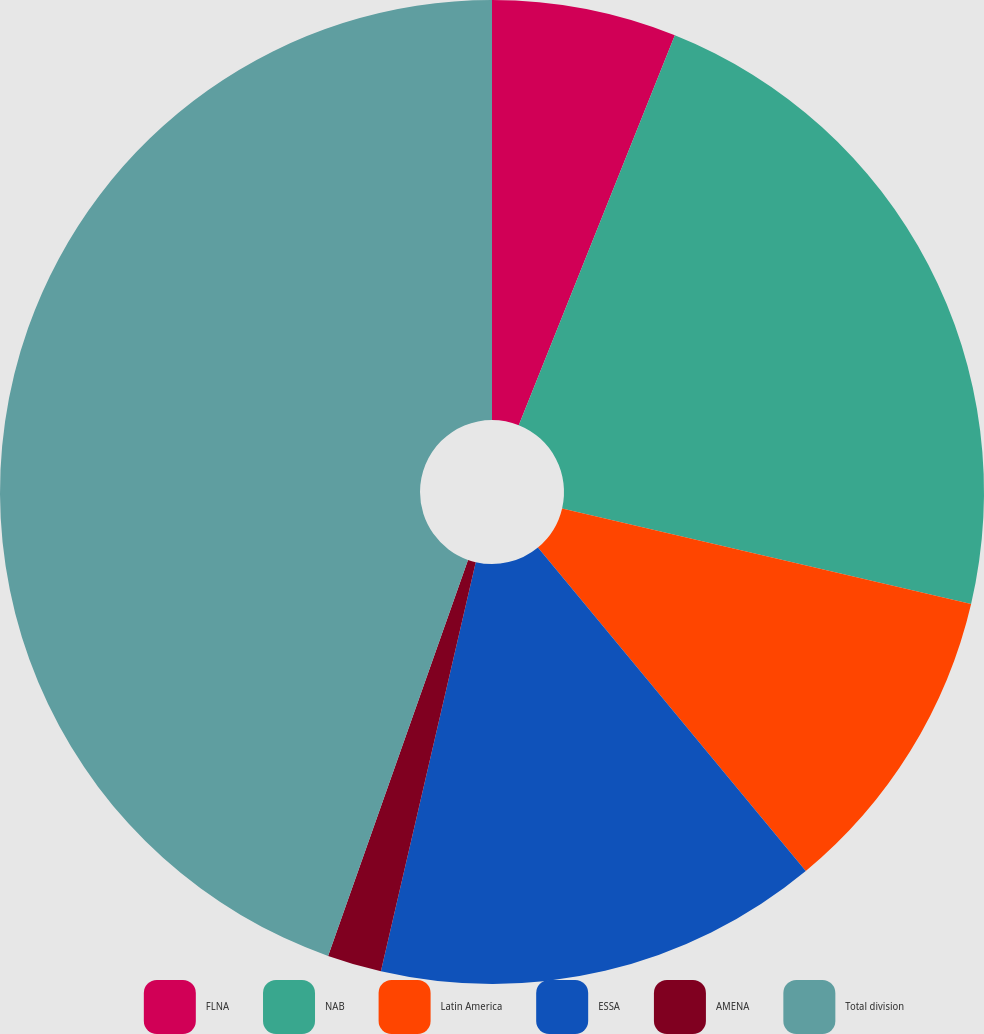Convert chart to OTSL. <chart><loc_0><loc_0><loc_500><loc_500><pie_chart><fcel>FLNA<fcel>NAB<fcel>Latin America<fcel>ESSA<fcel>AMENA<fcel>Total division<nl><fcel>6.06%<fcel>22.59%<fcel>10.34%<fcel>14.63%<fcel>1.78%<fcel>44.59%<nl></chart> 